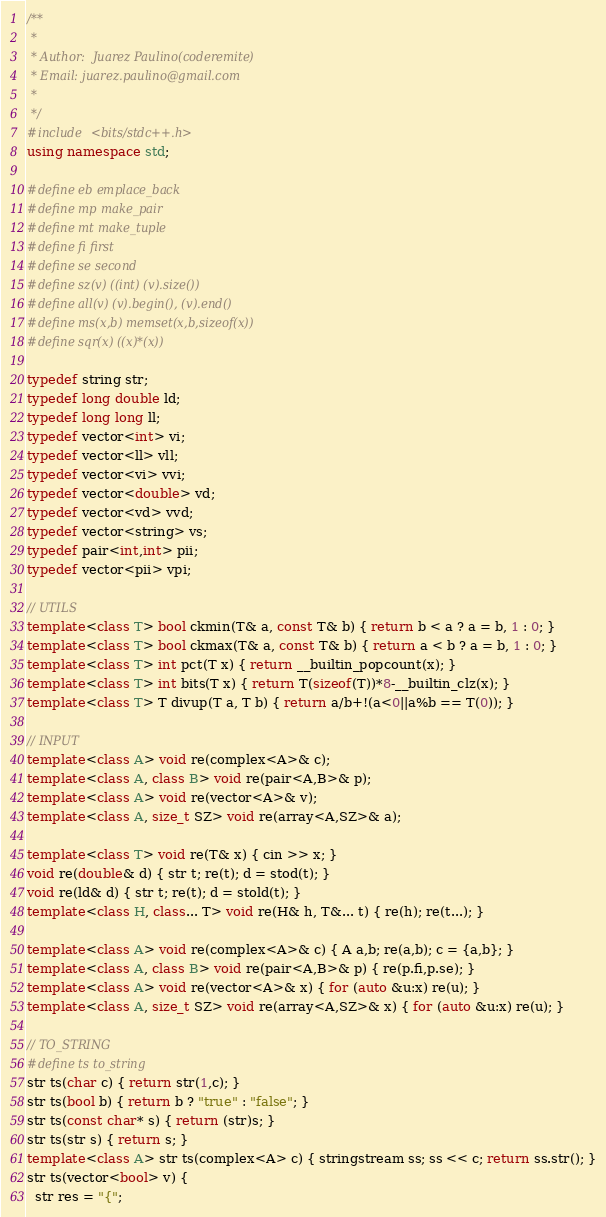Convert code to text. <code><loc_0><loc_0><loc_500><loc_500><_C++_>/**
 *
 * Author:  Juarez Paulino(coderemite)
 * Email: juarez.paulino@gmail.com
 *
 */
#include <bits/stdc++.h>
using namespace std;

#define eb emplace_back
#define mp make_pair
#define mt make_tuple
#define fi first
#define se second
#define sz(v) ((int) (v).size())
#define all(v) (v).begin(), (v).end()
#define ms(x,b) memset(x,b,sizeof(x))
#define sqr(x) ((x)*(x))

typedef string str;
typedef long double ld;
typedef long long ll;
typedef vector<int> vi;
typedef vector<ll> vll;
typedef vector<vi> vvi;
typedef vector<double> vd;
typedef vector<vd> vvd;
typedef vector<string> vs;
typedef pair<int,int> pii;
typedef vector<pii> vpi;

// UTILS
template<class T> bool ckmin(T& a, const T& b) { return b < a ? a = b, 1 : 0; }
template<class T> bool ckmax(T& a, const T& b) { return a < b ? a = b, 1 : 0; } 
template<class T> int pct(T x) { return __builtin_popcount(x); }
template<class T> int bits(T x) { return T(sizeof(T))*8-__builtin_clz(x); }
template<class T> T divup(T a, T b) { return a/b+!(a<0||a%b == T(0)); }

// INPUT
template<class A> void re(complex<A>& c);
template<class A, class B> void re(pair<A,B>& p);
template<class A> void re(vector<A>& v);
template<class A, size_t SZ> void re(array<A,SZ>& a);
 
template<class T> void re(T& x) { cin >> x; }
void re(double& d) { str t; re(t); d = stod(t); }
void re(ld& d) { str t; re(t); d = stold(t); }
template<class H, class... T> void re(H& h, T&... t) { re(h); re(t...); }
 
template<class A> void re(complex<A>& c) { A a,b; re(a,b); c = {a,b}; }
template<class A, class B> void re(pair<A,B>& p) { re(p.fi,p.se); }
template<class A> void re(vector<A>& x) { for (auto &u:x) re(u); }
template<class A, size_t SZ> void re(array<A,SZ>& x) { for (auto &u:x) re(u); }

// TO_STRING
#define ts to_string
str ts(char c) { return str(1,c); }
str ts(bool b) { return b ? "true" : "false"; }
str ts(const char* s) { return (str)s; }
str ts(str s) { return s; }
template<class A> str ts(complex<A> c) { stringstream ss; ss << c; return ss.str(); }
str ts(vector<bool> v) { 
  str res = "{";</code> 